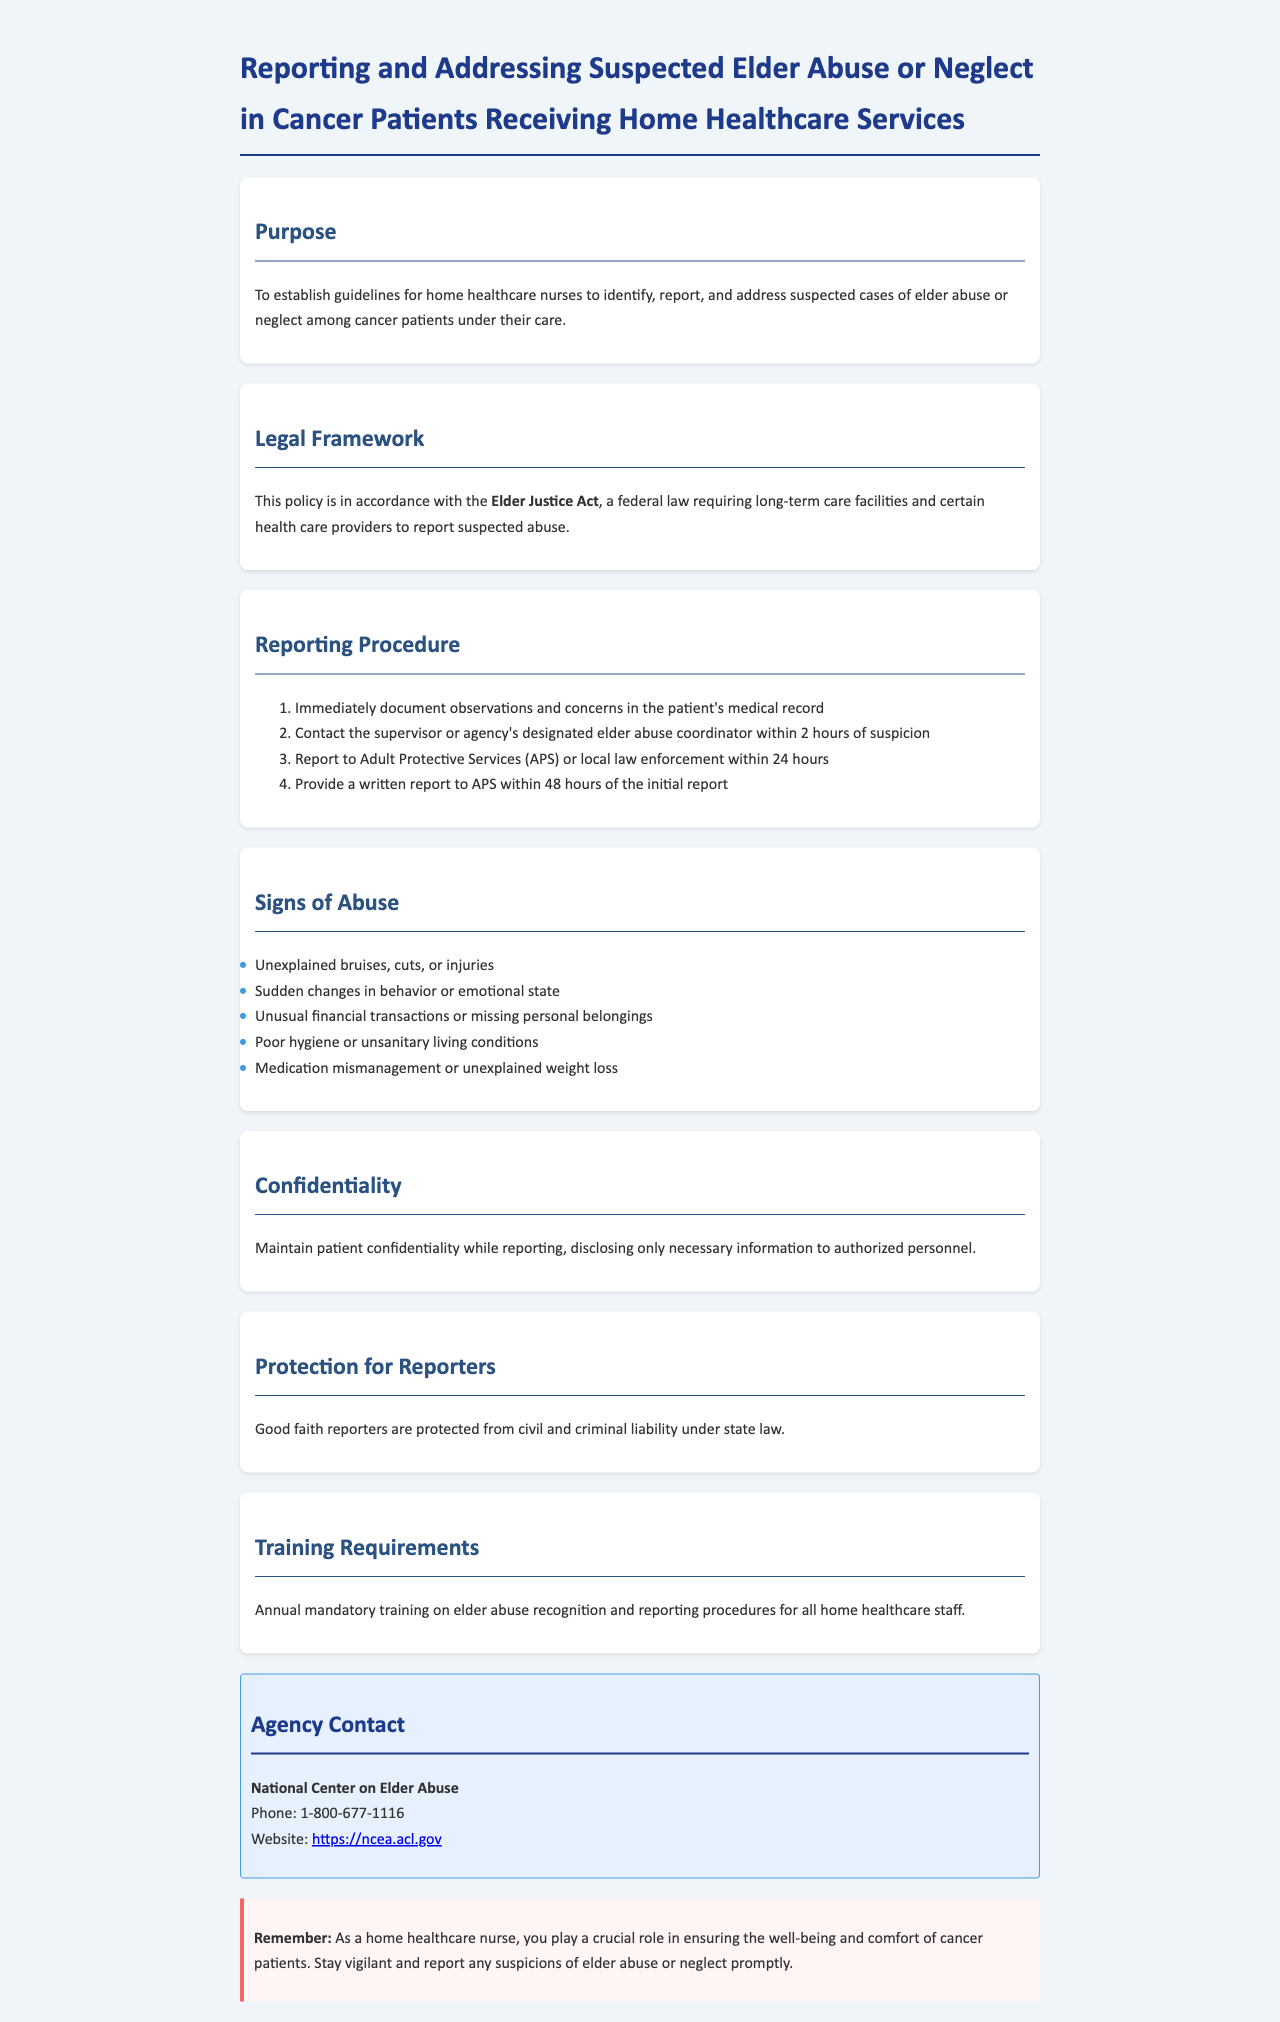What is the purpose of the policy? The purpose is to establish guidelines for home healthcare nurses to identify, report, and address suspected cases of elder abuse or neglect among cancer patients under their care.
Answer: To establish guidelines for home healthcare nurses What federal law is mentioned? The document states the policy is in accordance with the Elder Justice Act, which is a federal law.
Answer: Elder Justice Act How soon must a supervisor be contacted after suspicion arises? According to the reporting procedure, a supervisor or elder abuse coordinator must be contacted within 2 hours of suspicion.
Answer: 2 hours What are some signs of abuse listed? The document lists several signs, including unexplained bruises, cuts, or injuries.
Answer: Unexplained bruises, cuts, or injuries What is the timeframe for reporting to Adult Protective Services? The policy states that reports must be made to APS or local law enforcement within 24 hours of suspicion.
Answer: 24 hours What type of training is required annually? The policy specifies that there is annual mandatory training on elder abuse recognition and reporting procedures for all home healthcare staff.
Answer: Annual mandatory training What protects good faith reporters? The document states that good faith reporters are protected from civil and criminal liability under state law.
Answer: Civil and criminal liability protection What is emphasized in the warning section? The warning section emphasizes the crucial role of home healthcare nurses in ensuring the well-being and comfort of cancer patients.
Answer: Ensuring the well-being and comfort of cancer patients 